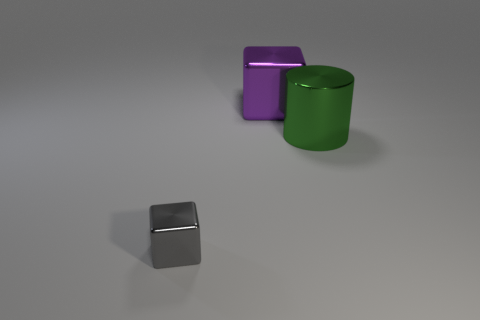What mood or artistic concept could this arrangement of shapes represent? The interplay of simple geometric shapes in muted colors against a neutral background could represent a minimalist aesthetic, conveying a sense of calm and order. The lighting is soft and uniform, which adds to the tranquil mood. The composition could also be seen as a study in form and depth, challenging the viewer to consider the relationship between objects and space. 